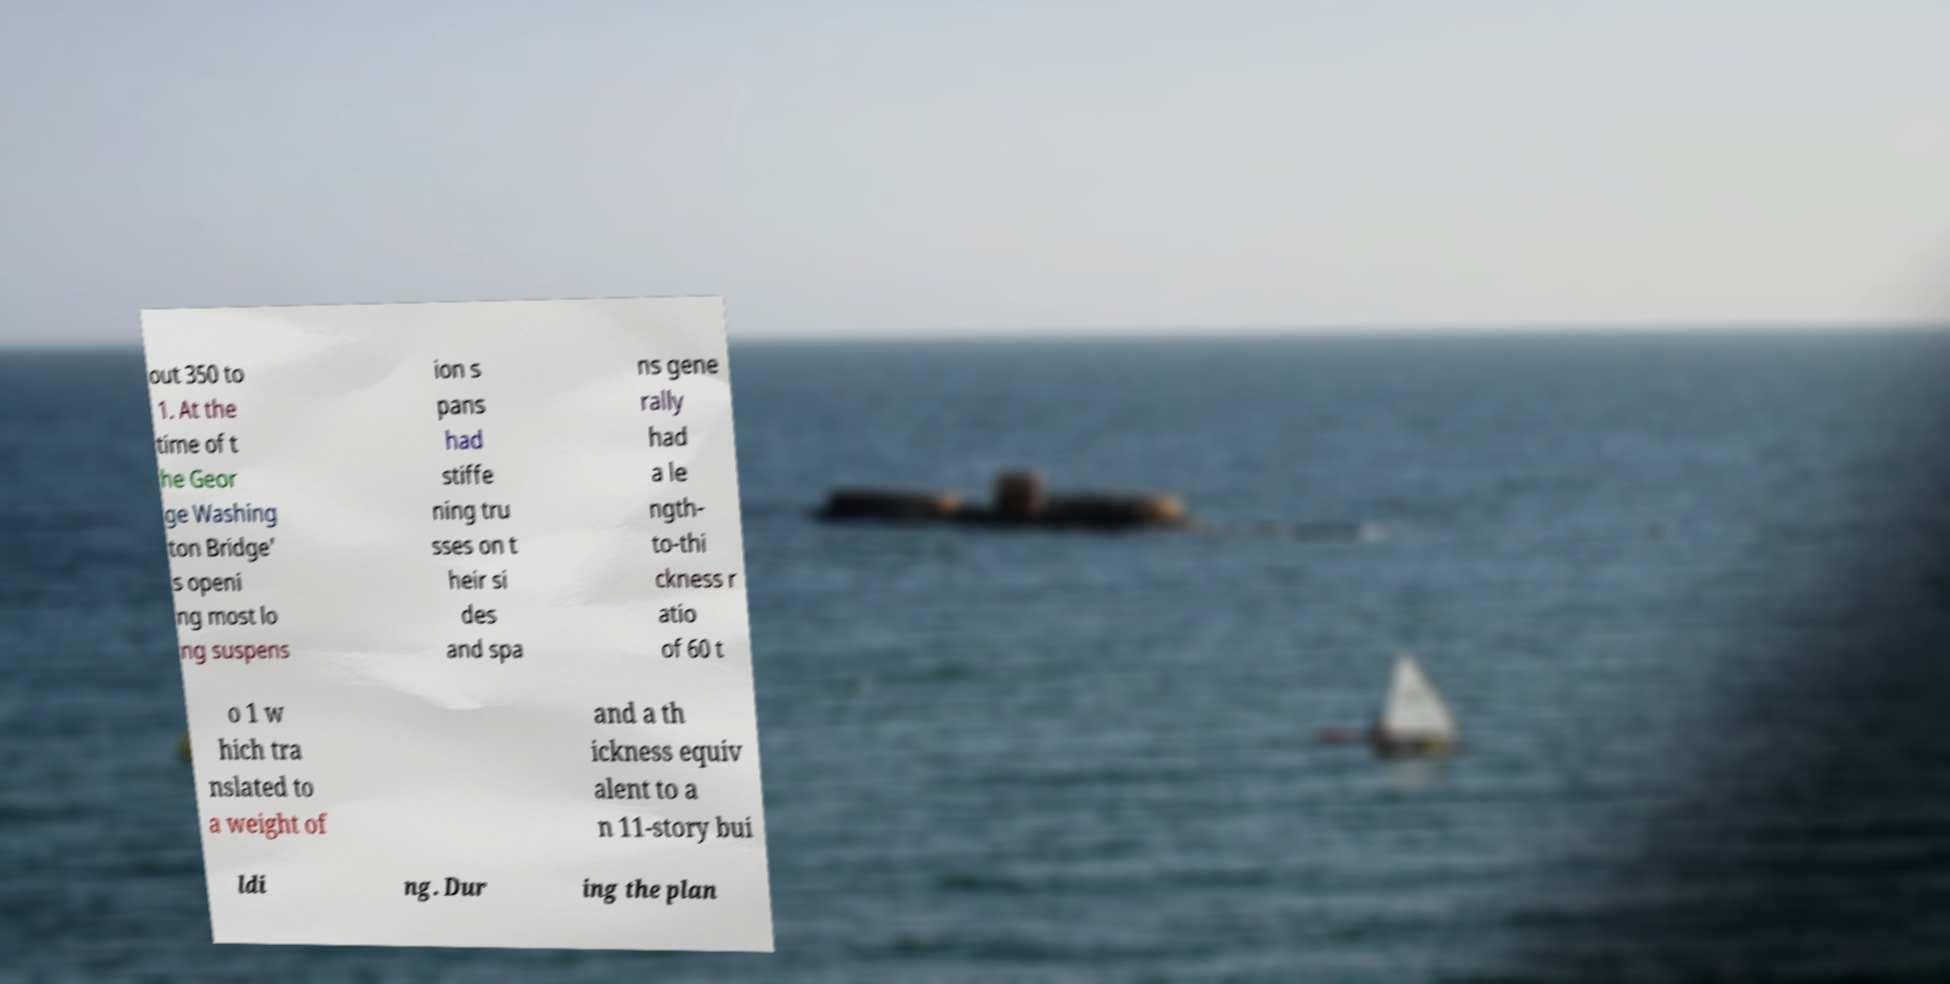Can you accurately transcribe the text from the provided image for me? out 350 to 1. At the time of t he Geor ge Washing ton Bridge' s openi ng most lo ng suspens ion s pans had stiffe ning tru sses on t heir si des and spa ns gene rally had a le ngth- to-thi ckness r atio of 60 t o 1 w hich tra nslated to a weight of and a th ickness equiv alent to a n 11-story bui ldi ng. Dur ing the plan 